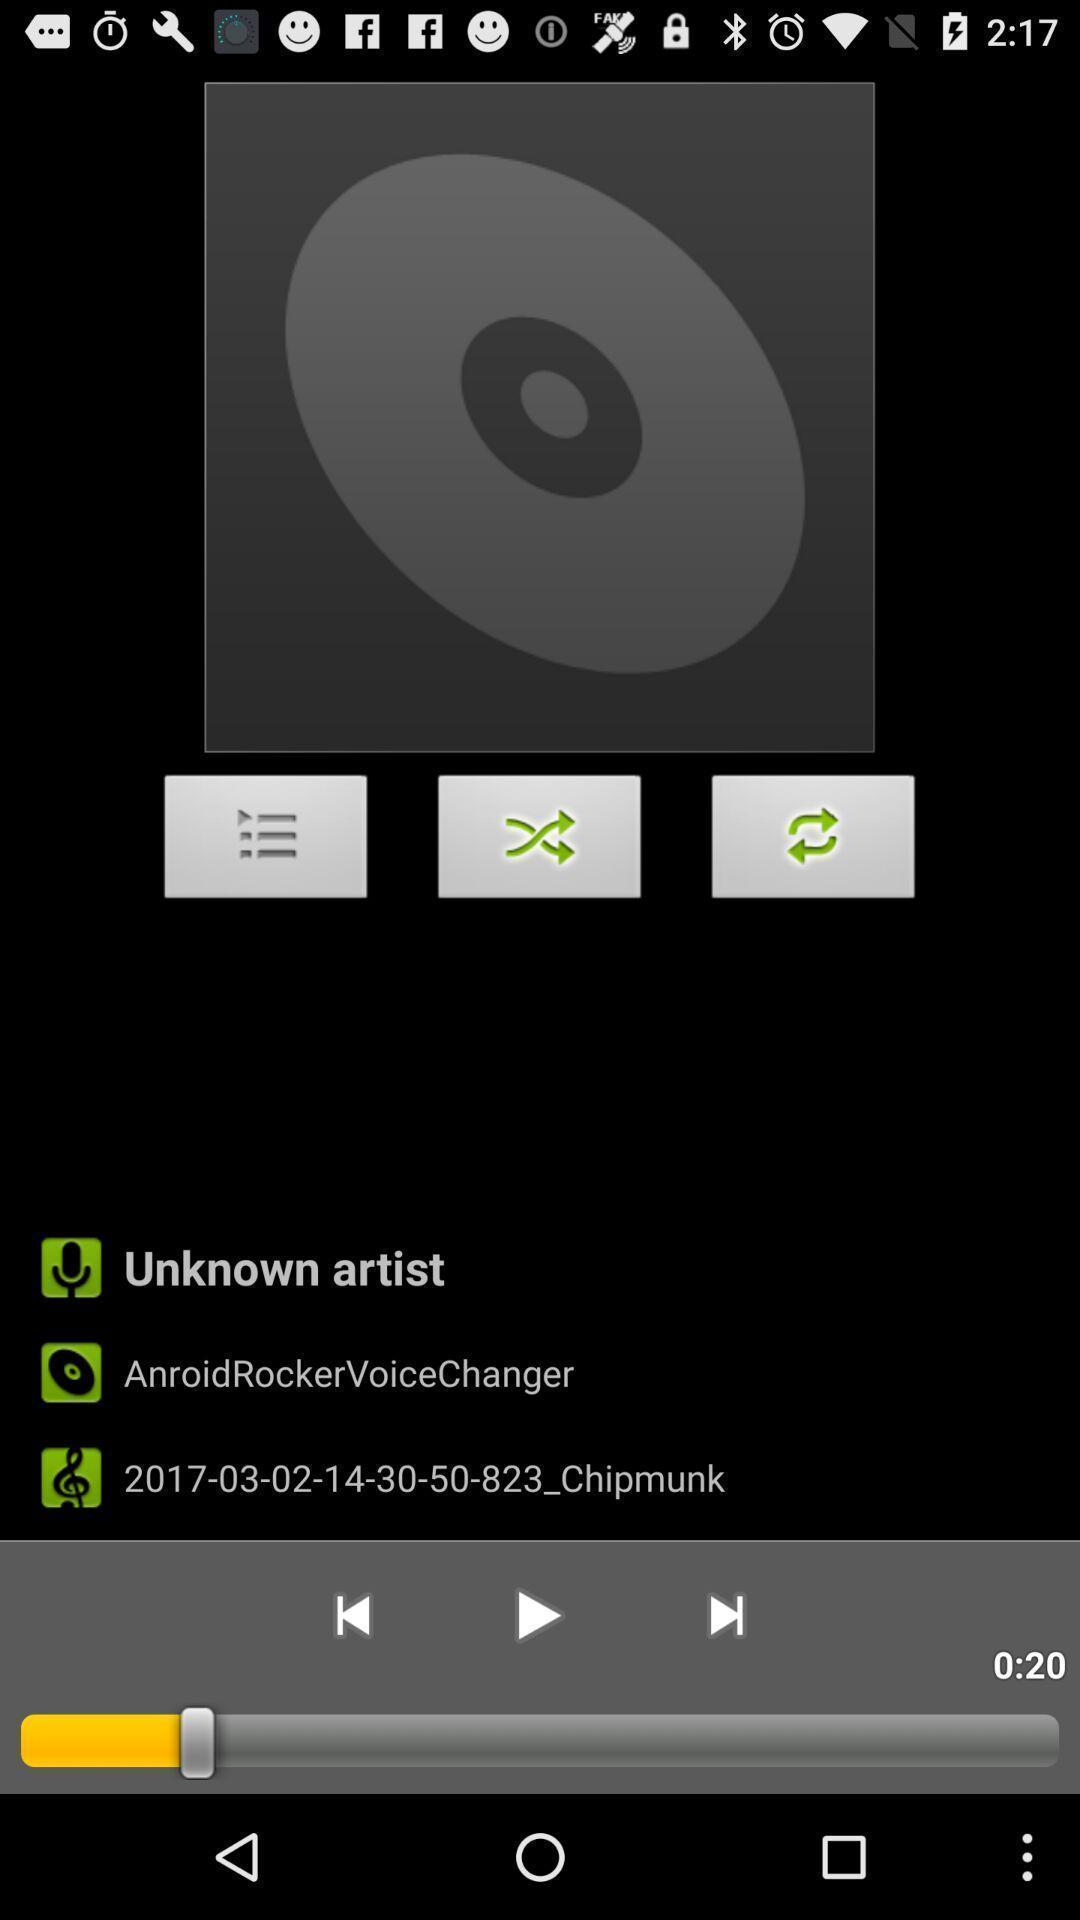Summarize the main components in this picture. Voice and sound controls of a musical app. 